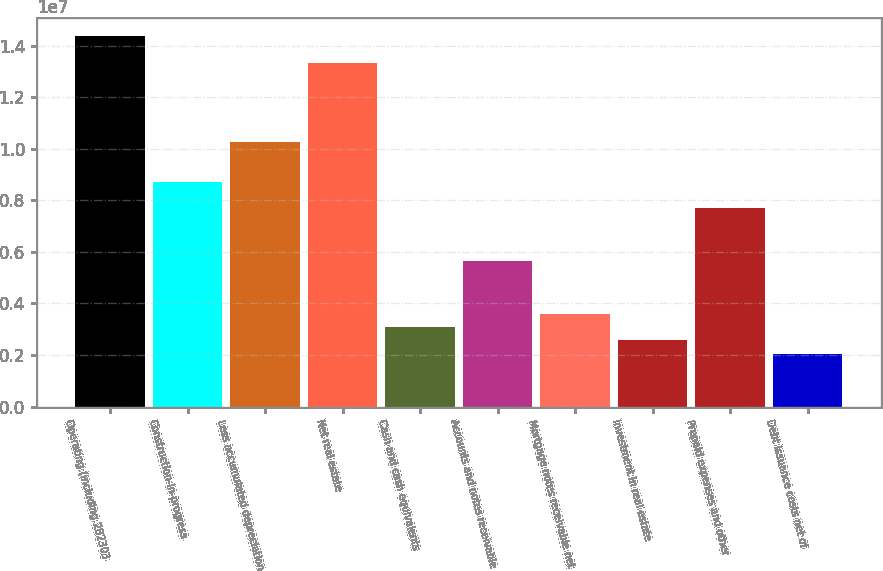Convert chart to OTSL. <chart><loc_0><loc_0><loc_500><loc_500><bar_chart><fcel>Operating (including 282303<fcel>Construction-in-progress<fcel>Less accumulated depreciation<fcel>Net real estate<fcel>Cash and cash equivalents<fcel>Accounts and notes receivable<fcel>Mortgage notes receivable net<fcel>Investment in real estate<fcel>Prepaid expenses and other<fcel>Debt issuance costs net of<nl><fcel>1.43593e+07<fcel>8.71841e+06<fcel>1.02568e+07<fcel>1.33337e+07<fcel>3.07753e+06<fcel>5.64156e+06<fcel>3.59034e+06<fcel>2.56472e+06<fcel>7.69279e+06<fcel>2.05192e+06<nl></chart> 